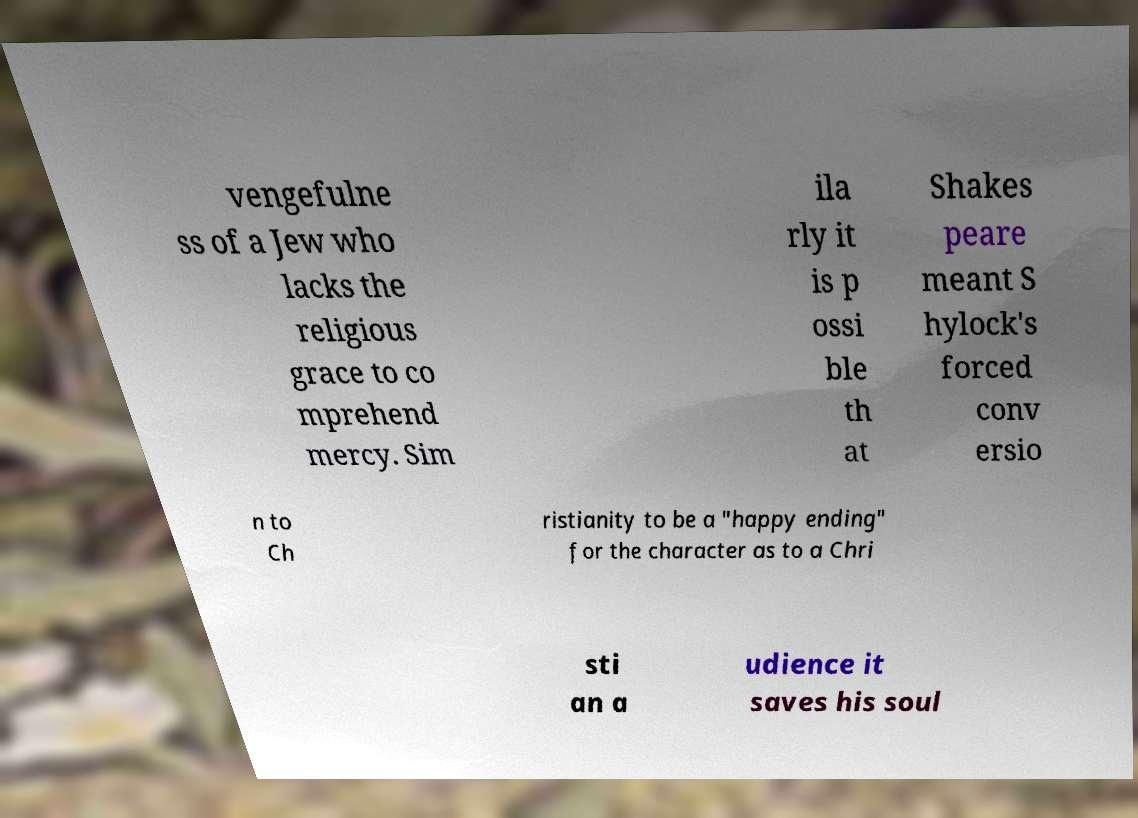I need the written content from this picture converted into text. Can you do that? vengefulne ss of a Jew who lacks the religious grace to co mprehend mercy. Sim ila rly it is p ossi ble th at Shakes peare meant S hylock's forced conv ersio n to Ch ristianity to be a "happy ending" for the character as to a Chri sti an a udience it saves his soul 